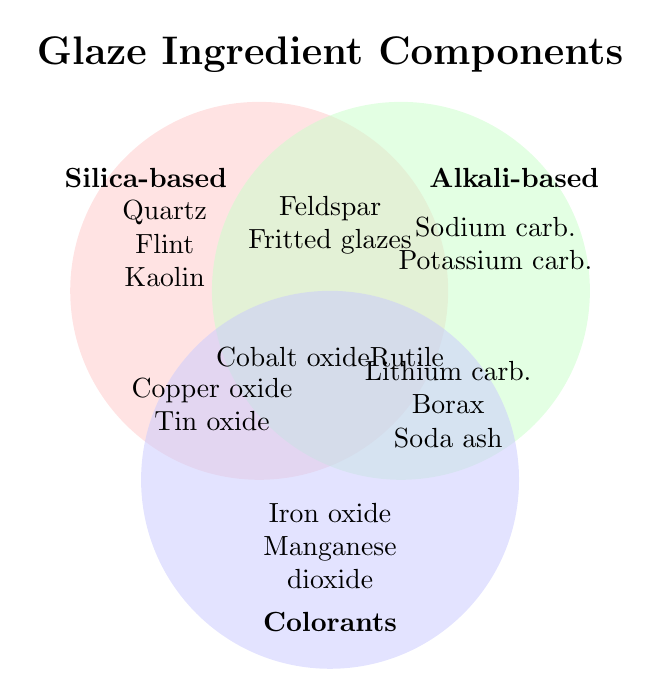Which color is used to represent Silica-based ingredients? The Venn Diagram uses specific colors to distinguish the three ingredient sets. Silica-based ingredients are shown with a pink shade.
Answer: Pink List all the colorants mentioned in the diagram. The colorants are shown in the blue circle at the bottom of the Venn Diagram. They include Iron oxide and Manganese dioxide.
Answer: Iron oxide, Manganese dioxide What ingredients are common between Silica-based and Alkali-based? The shared space between Silica-based and Alkali-based circles includes the ingredients Feldspar and Fritted glazes.
Answer: Feldspar, Fritted glazes How many ingredients belong exclusively to Silica-based set? The exclusive ingredients in the Silica-based circle include Quartz, Flint, and Kaolin, which are three in total.
Answer: 3 Which ingredient is found in all three sets? The ingredient positioned at the overlapping area of all three sets (A∩B∩C) is Cobalt oxide and Rutile.
Answer: Cobalt oxide, Rutile Identify an ingredient that belongs to both Alkali-based and Colorants but not Silica-based. The overlapped area between Alkali-based and Colorants but excluding Silica-based shows Lithium carbonate, Borax, and Soda ash.
Answer: Lithium carbonate, Borax, Soda ash How many ingredients are shared between Silica-based and Colorants and not in Alkali-based? The shared ingredients between Silica-based and Colorants, excluding Alkali-based, are Copper oxide and Tin oxide.
Answer: 2 What ingredient category does Potassium carbonate belong to? Potassium carbonate is located within the solid green upper right circle representing Alkali-based ingredients.
Answer: Alkali-based Name ingredients that are neither Silica-based nor Colorants. Ingredients outside Silica-based and Colorants circles but within the Alkali-based circle are Sodium carbonate, Potassium carbonate.
Answer: Sodium carbonate, Potassium carbonate Which ingredient categories share the highest number of common ingredients? The shared area between Alkali-based and Colorants categories has the highest number of common ingredients, which are Lithium carbonate, Borax, and Soda Ash (3 ingredients).
Answer: Alkali-based and Colorants 